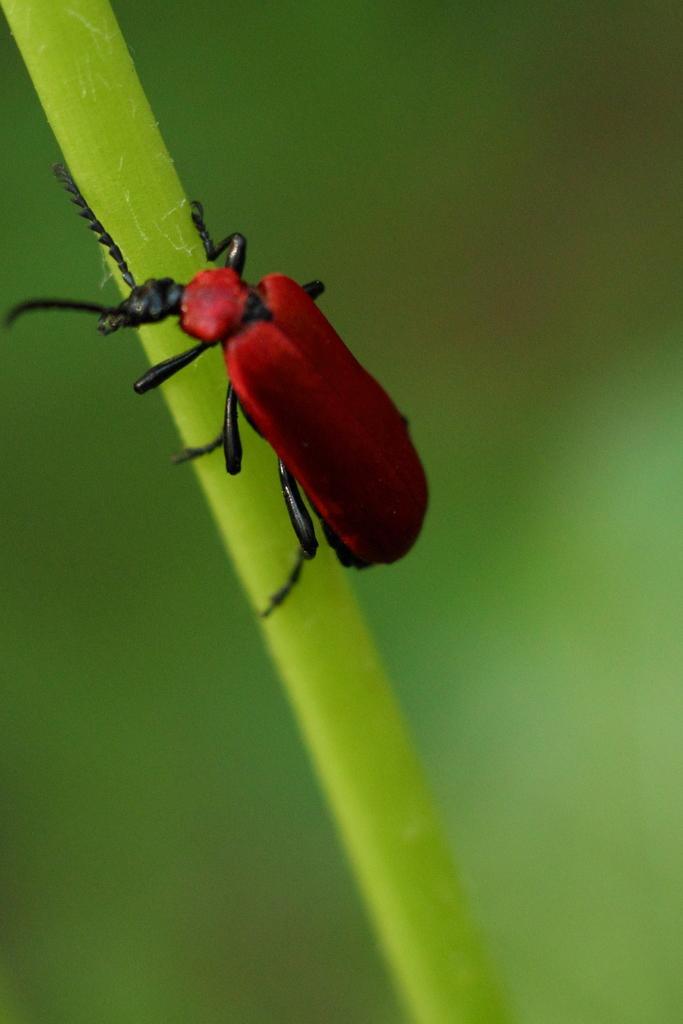Describe this image in one or two sentences. Here in this picture we can see a soldier beetle present on a plant over there. 